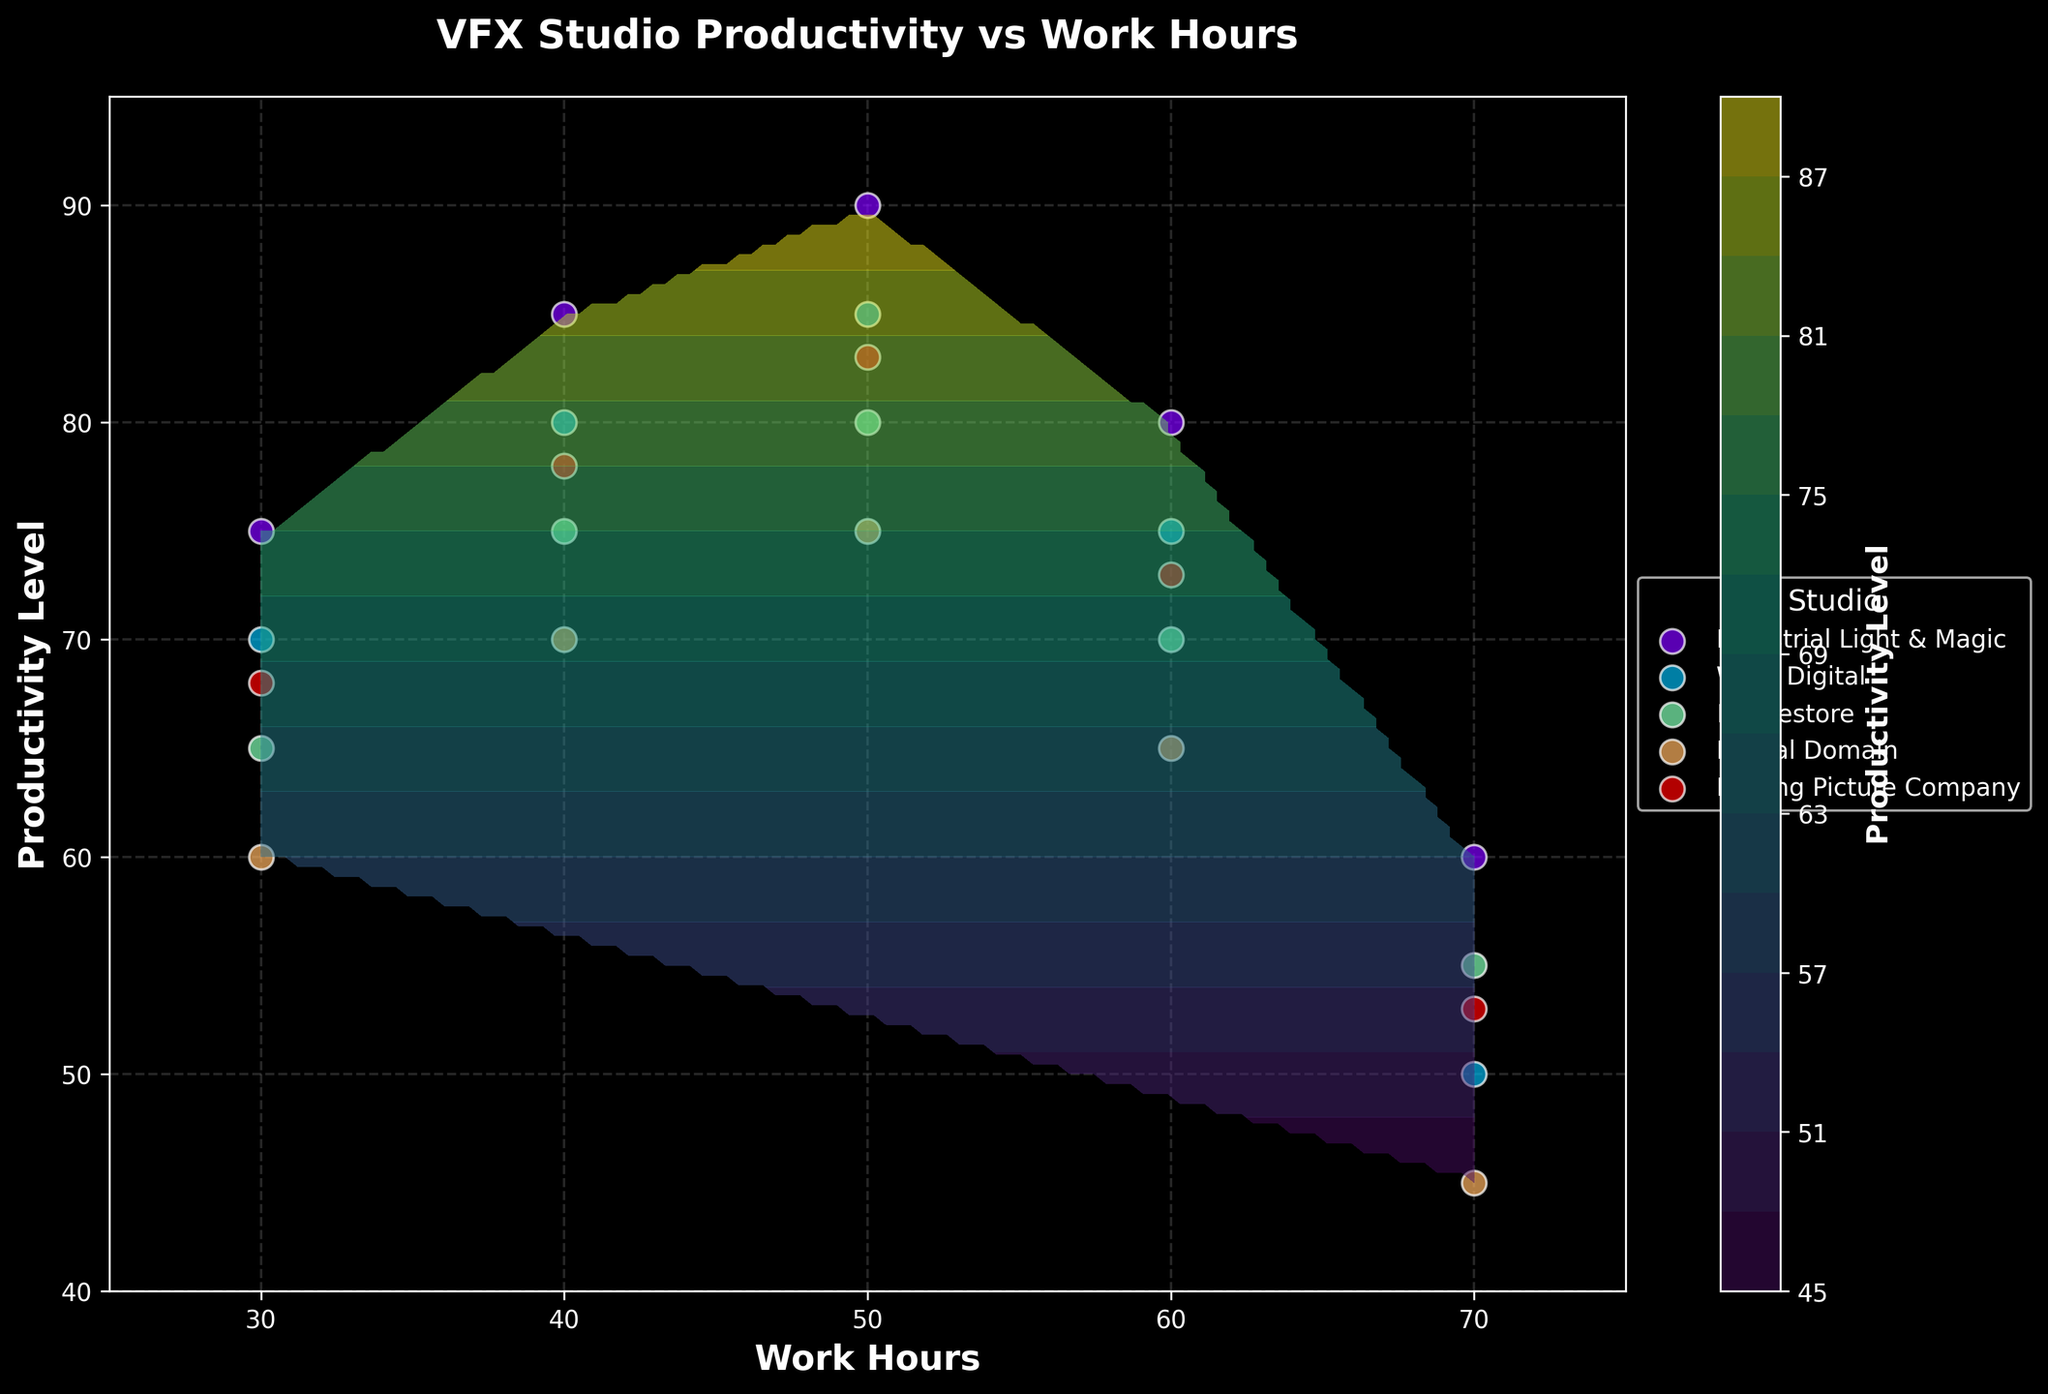what is the title of the figure? The title is typically found at the top center of the figure in bold text. It describes the main subject of the data presented in the plot. The title of this figure is "VFX Studio Productivity vs Work Hours".
Answer: VFX Studio Productivity vs Work Hours how many studio environments are displayed in the figure? To determine the number of studio environments, observe the legend on the right side. Each unique label in the legend represents a different studio environment. Counting these labels gives the answer.
Answer: 5 which studio has the highest productivity level at 50 work hours? By examining the scatter points where the x-axis is 50, compare the corresponding y-values. The studio with the highest y-value at this x-value represents the highest productivity level at 50 work hours.
Answer: Industrial Light & Magic what is the color of the contour lines representing the highest productivity levels? Look at the contour plot's color gradient to identify the colors representing different productivity levels. The highest productivity levels are usually depicted by the lightest or most intense color on the color bar legend.
Answer: Light green/yellow which studio shows a productivity drop from 60 to 70 work hours? Check the scatter plot section where the x-values are between 60 and 70 work hours. Compare the y-values (productivity levels) of different studios to see which line has a downward trend.
Answer: All studios what is the range of work hours displayed on the x-axis? Observe the x-axis to find the minimum and maximum values labeled on this axis. This provides the range of work hours displayed. The x-axis ranges from 25 to 75.
Answer: 25 to 75 how does the productivity level generally change as work hours increase from 30 to 50 for Weta Digital? Look at the scatter points and their trend for Weta Digital between 30 and 50 work hours. Identify whether the y-values (productivity) are increasing, decreasing, or staying constant.
Answer: Increases compare the productivity levels at 40 work hours between Moving Picture Company and Framestore. Locate the scatter points for 40 work hours on the x-axis. Compare the y-values at this x-value for both Moving Picture Company and Framestore to determine which has a higher productivity level.
Answer: Moving Picture Company has higher productivity what is the general shape of the contour lines? Contour lines connect regions of equal productivity levels and can form various shapes like circles, ellipses, or complex curves. Observing the overall layout of these lines can give an idea of their general shape.
Answer: Smooth curves what does the color bar indicate on the right side? The color bar acts as a legend for the contour plot, showing which colors correspond to different intensity levels. Read the labels on the color bar to understand what it represents.
Answer: Productivity Level 